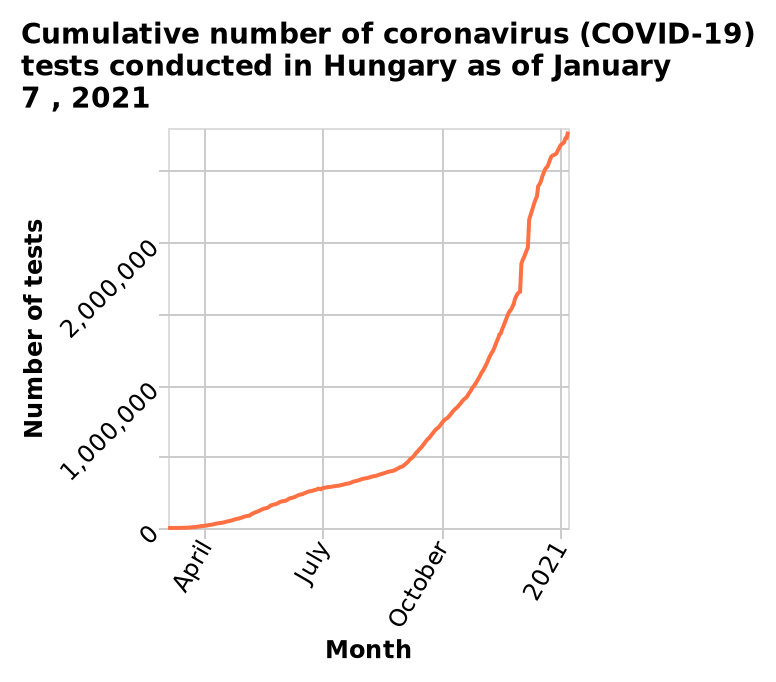<image>
What is the range of the y-axis on the line chart?  The y-axis shows the number of tests conducted, ranging from 0 to 2,500,000. What is the highest number of tests conducted in Hungary shown on the line chart?  The highest number of tests conducted in Hungary shown on the line chart is 2,500,000. When was there almost no covid cases?  There were almost no covid cases in late March. Were there any covid cases in late March? No, there were almost no covid cases in late March. When was the cumulative number of COVID-19 tests conducted in Hungary last updated?  The cumulative number of COVID-19 tests conducted in Hungary was last updated on January 7, 2021. How many covid cases were there by the end of 2020?  By the end of 2020, there were over 2.5 million covid cases. Does the y-axis show the number of tests conducted, ranging from 0 to 500? No. The y-axis shows the number of tests conducted, ranging from 0 to 2,500,000. 